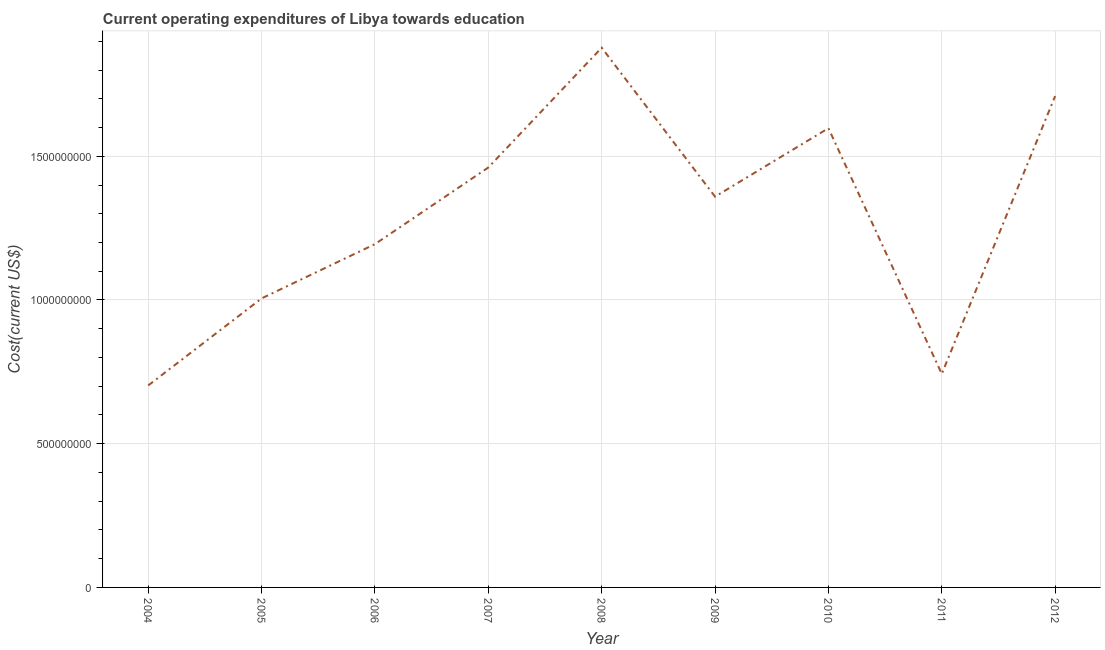What is the education expenditure in 2012?
Your answer should be compact. 1.71e+09. Across all years, what is the maximum education expenditure?
Offer a very short reply. 1.88e+09. Across all years, what is the minimum education expenditure?
Provide a succinct answer. 7.03e+08. What is the sum of the education expenditure?
Your answer should be compact. 1.17e+1. What is the difference between the education expenditure in 2009 and 2011?
Provide a succinct answer. 6.17e+08. What is the average education expenditure per year?
Your answer should be compact. 1.29e+09. What is the median education expenditure?
Offer a terse response. 1.36e+09. In how many years, is the education expenditure greater than 800000000 US$?
Provide a succinct answer. 7. What is the ratio of the education expenditure in 2004 to that in 2005?
Your answer should be very brief. 0.7. Is the education expenditure in 2008 less than that in 2012?
Give a very brief answer. No. What is the difference between the highest and the second highest education expenditure?
Your response must be concise. 1.68e+08. Is the sum of the education expenditure in 2004 and 2006 greater than the maximum education expenditure across all years?
Your response must be concise. Yes. What is the difference between the highest and the lowest education expenditure?
Offer a very short reply. 1.17e+09. In how many years, is the education expenditure greater than the average education expenditure taken over all years?
Ensure brevity in your answer.  5. How many years are there in the graph?
Provide a short and direct response. 9. Are the values on the major ticks of Y-axis written in scientific E-notation?
Your answer should be compact. No. What is the title of the graph?
Your answer should be very brief. Current operating expenditures of Libya towards education. What is the label or title of the X-axis?
Give a very brief answer. Year. What is the label or title of the Y-axis?
Your answer should be compact. Cost(current US$). What is the Cost(current US$) of 2004?
Your response must be concise. 7.03e+08. What is the Cost(current US$) in 2005?
Provide a succinct answer. 1.01e+09. What is the Cost(current US$) of 2006?
Offer a terse response. 1.19e+09. What is the Cost(current US$) in 2007?
Make the answer very short. 1.46e+09. What is the Cost(current US$) in 2008?
Keep it short and to the point. 1.88e+09. What is the Cost(current US$) of 2009?
Offer a terse response. 1.36e+09. What is the Cost(current US$) in 2010?
Provide a short and direct response. 1.60e+09. What is the Cost(current US$) of 2011?
Provide a succinct answer. 7.43e+08. What is the Cost(current US$) in 2012?
Keep it short and to the point. 1.71e+09. What is the difference between the Cost(current US$) in 2004 and 2005?
Offer a very short reply. -3.03e+08. What is the difference between the Cost(current US$) in 2004 and 2006?
Your answer should be compact. -4.92e+08. What is the difference between the Cost(current US$) in 2004 and 2007?
Offer a terse response. -7.58e+08. What is the difference between the Cost(current US$) in 2004 and 2008?
Your answer should be compact. -1.17e+09. What is the difference between the Cost(current US$) in 2004 and 2009?
Make the answer very short. -6.57e+08. What is the difference between the Cost(current US$) in 2004 and 2010?
Keep it short and to the point. -8.95e+08. What is the difference between the Cost(current US$) in 2004 and 2011?
Your answer should be very brief. -4.02e+07. What is the difference between the Cost(current US$) in 2004 and 2012?
Make the answer very short. -1.01e+09. What is the difference between the Cost(current US$) in 2005 and 2006?
Provide a succinct answer. -1.89e+08. What is the difference between the Cost(current US$) in 2005 and 2007?
Make the answer very short. -4.55e+08. What is the difference between the Cost(current US$) in 2005 and 2008?
Keep it short and to the point. -8.72e+08. What is the difference between the Cost(current US$) in 2005 and 2009?
Provide a succinct answer. -3.54e+08. What is the difference between the Cost(current US$) in 2005 and 2010?
Provide a short and direct response. -5.92e+08. What is the difference between the Cost(current US$) in 2005 and 2011?
Your answer should be compact. 2.63e+08. What is the difference between the Cost(current US$) in 2005 and 2012?
Your answer should be compact. -7.04e+08. What is the difference between the Cost(current US$) in 2006 and 2007?
Your response must be concise. -2.67e+08. What is the difference between the Cost(current US$) in 2006 and 2008?
Your response must be concise. -6.83e+08. What is the difference between the Cost(current US$) in 2006 and 2009?
Offer a very short reply. -1.65e+08. What is the difference between the Cost(current US$) in 2006 and 2010?
Your answer should be compact. -4.03e+08. What is the difference between the Cost(current US$) in 2006 and 2011?
Ensure brevity in your answer.  4.51e+08. What is the difference between the Cost(current US$) in 2006 and 2012?
Offer a very short reply. -5.15e+08. What is the difference between the Cost(current US$) in 2007 and 2008?
Your answer should be compact. -4.17e+08. What is the difference between the Cost(current US$) in 2007 and 2009?
Make the answer very short. 1.01e+08. What is the difference between the Cost(current US$) in 2007 and 2010?
Your response must be concise. -1.37e+08. What is the difference between the Cost(current US$) in 2007 and 2011?
Offer a terse response. 7.18e+08. What is the difference between the Cost(current US$) in 2007 and 2012?
Give a very brief answer. -2.48e+08. What is the difference between the Cost(current US$) in 2008 and 2009?
Your response must be concise. 5.18e+08. What is the difference between the Cost(current US$) in 2008 and 2010?
Provide a short and direct response. 2.80e+08. What is the difference between the Cost(current US$) in 2008 and 2011?
Provide a succinct answer. 1.13e+09. What is the difference between the Cost(current US$) in 2008 and 2012?
Offer a very short reply. 1.68e+08. What is the difference between the Cost(current US$) in 2009 and 2010?
Offer a terse response. -2.38e+08. What is the difference between the Cost(current US$) in 2009 and 2011?
Your response must be concise. 6.17e+08. What is the difference between the Cost(current US$) in 2009 and 2012?
Your answer should be very brief. -3.50e+08. What is the difference between the Cost(current US$) in 2010 and 2011?
Give a very brief answer. 8.55e+08. What is the difference between the Cost(current US$) in 2010 and 2012?
Give a very brief answer. -1.12e+08. What is the difference between the Cost(current US$) in 2011 and 2012?
Offer a terse response. -9.67e+08. What is the ratio of the Cost(current US$) in 2004 to that in 2005?
Offer a very short reply. 0.7. What is the ratio of the Cost(current US$) in 2004 to that in 2006?
Offer a very short reply. 0.59. What is the ratio of the Cost(current US$) in 2004 to that in 2007?
Give a very brief answer. 0.48. What is the ratio of the Cost(current US$) in 2004 to that in 2008?
Offer a terse response. 0.37. What is the ratio of the Cost(current US$) in 2004 to that in 2009?
Keep it short and to the point. 0.52. What is the ratio of the Cost(current US$) in 2004 to that in 2010?
Give a very brief answer. 0.44. What is the ratio of the Cost(current US$) in 2004 to that in 2011?
Provide a succinct answer. 0.95. What is the ratio of the Cost(current US$) in 2004 to that in 2012?
Offer a terse response. 0.41. What is the ratio of the Cost(current US$) in 2005 to that in 2006?
Ensure brevity in your answer.  0.84. What is the ratio of the Cost(current US$) in 2005 to that in 2007?
Offer a terse response. 0.69. What is the ratio of the Cost(current US$) in 2005 to that in 2008?
Your answer should be very brief. 0.54. What is the ratio of the Cost(current US$) in 2005 to that in 2009?
Your answer should be very brief. 0.74. What is the ratio of the Cost(current US$) in 2005 to that in 2010?
Provide a succinct answer. 0.63. What is the ratio of the Cost(current US$) in 2005 to that in 2011?
Provide a short and direct response. 1.35. What is the ratio of the Cost(current US$) in 2005 to that in 2012?
Offer a very short reply. 0.59. What is the ratio of the Cost(current US$) in 2006 to that in 2007?
Provide a short and direct response. 0.82. What is the ratio of the Cost(current US$) in 2006 to that in 2008?
Your response must be concise. 0.64. What is the ratio of the Cost(current US$) in 2006 to that in 2009?
Provide a succinct answer. 0.88. What is the ratio of the Cost(current US$) in 2006 to that in 2010?
Provide a succinct answer. 0.75. What is the ratio of the Cost(current US$) in 2006 to that in 2011?
Give a very brief answer. 1.61. What is the ratio of the Cost(current US$) in 2006 to that in 2012?
Make the answer very short. 0.7. What is the ratio of the Cost(current US$) in 2007 to that in 2008?
Provide a short and direct response. 0.78. What is the ratio of the Cost(current US$) in 2007 to that in 2009?
Provide a short and direct response. 1.07. What is the ratio of the Cost(current US$) in 2007 to that in 2010?
Your answer should be compact. 0.91. What is the ratio of the Cost(current US$) in 2007 to that in 2011?
Give a very brief answer. 1.97. What is the ratio of the Cost(current US$) in 2007 to that in 2012?
Ensure brevity in your answer.  0.85. What is the ratio of the Cost(current US$) in 2008 to that in 2009?
Your response must be concise. 1.38. What is the ratio of the Cost(current US$) in 2008 to that in 2010?
Provide a short and direct response. 1.18. What is the ratio of the Cost(current US$) in 2008 to that in 2011?
Keep it short and to the point. 2.53. What is the ratio of the Cost(current US$) in 2008 to that in 2012?
Ensure brevity in your answer.  1.1. What is the ratio of the Cost(current US$) in 2009 to that in 2010?
Provide a short and direct response. 0.85. What is the ratio of the Cost(current US$) in 2009 to that in 2011?
Your answer should be very brief. 1.83. What is the ratio of the Cost(current US$) in 2009 to that in 2012?
Provide a short and direct response. 0.8. What is the ratio of the Cost(current US$) in 2010 to that in 2011?
Your answer should be very brief. 2.15. What is the ratio of the Cost(current US$) in 2010 to that in 2012?
Make the answer very short. 0.94. What is the ratio of the Cost(current US$) in 2011 to that in 2012?
Provide a short and direct response. 0.43. 